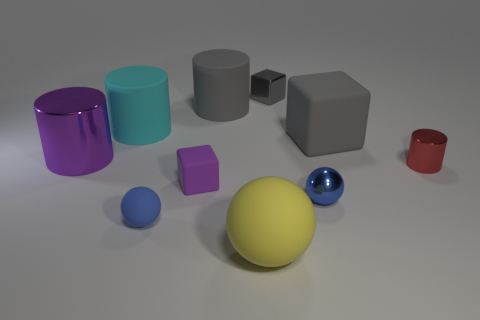Are there any purple shiny blocks that have the same size as the purple metallic cylinder?
Your answer should be very brief. No. The big matte object in front of the shiny cylinder that is behind the red shiny object is what color?
Keep it short and to the point. Yellow. What number of big cylinders are there?
Provide a succinct answer. 3. Is the color of the tiny matte cube the same as the big metallic cylinder?
Your answer should be compact. Yes. Is the number of large cyan cylinders that are in front of the purple cylinder less than the number of tiny purple cubes that are left of the tiny purple matte block?
Your answer should be compact. No. The small matte cube is what color?
Your response must be concise. Purple. How many cylinders are the same color as the metal cube?
Ensure brevity in your answer.  1. Are there any cubes to the left of the blue metallic sphere?
Your answer should be very brief. Yes. Are there an equal number of tiny red metallic cylinders behind the red thing and cyan rubber objects in front of the large cyan cylinder?
Give a very brief answer. Yes. Do the metal object behind the big metal cylinder and the shiny thing in front of the red object have the same size?
Your response must be concise. Yes. 